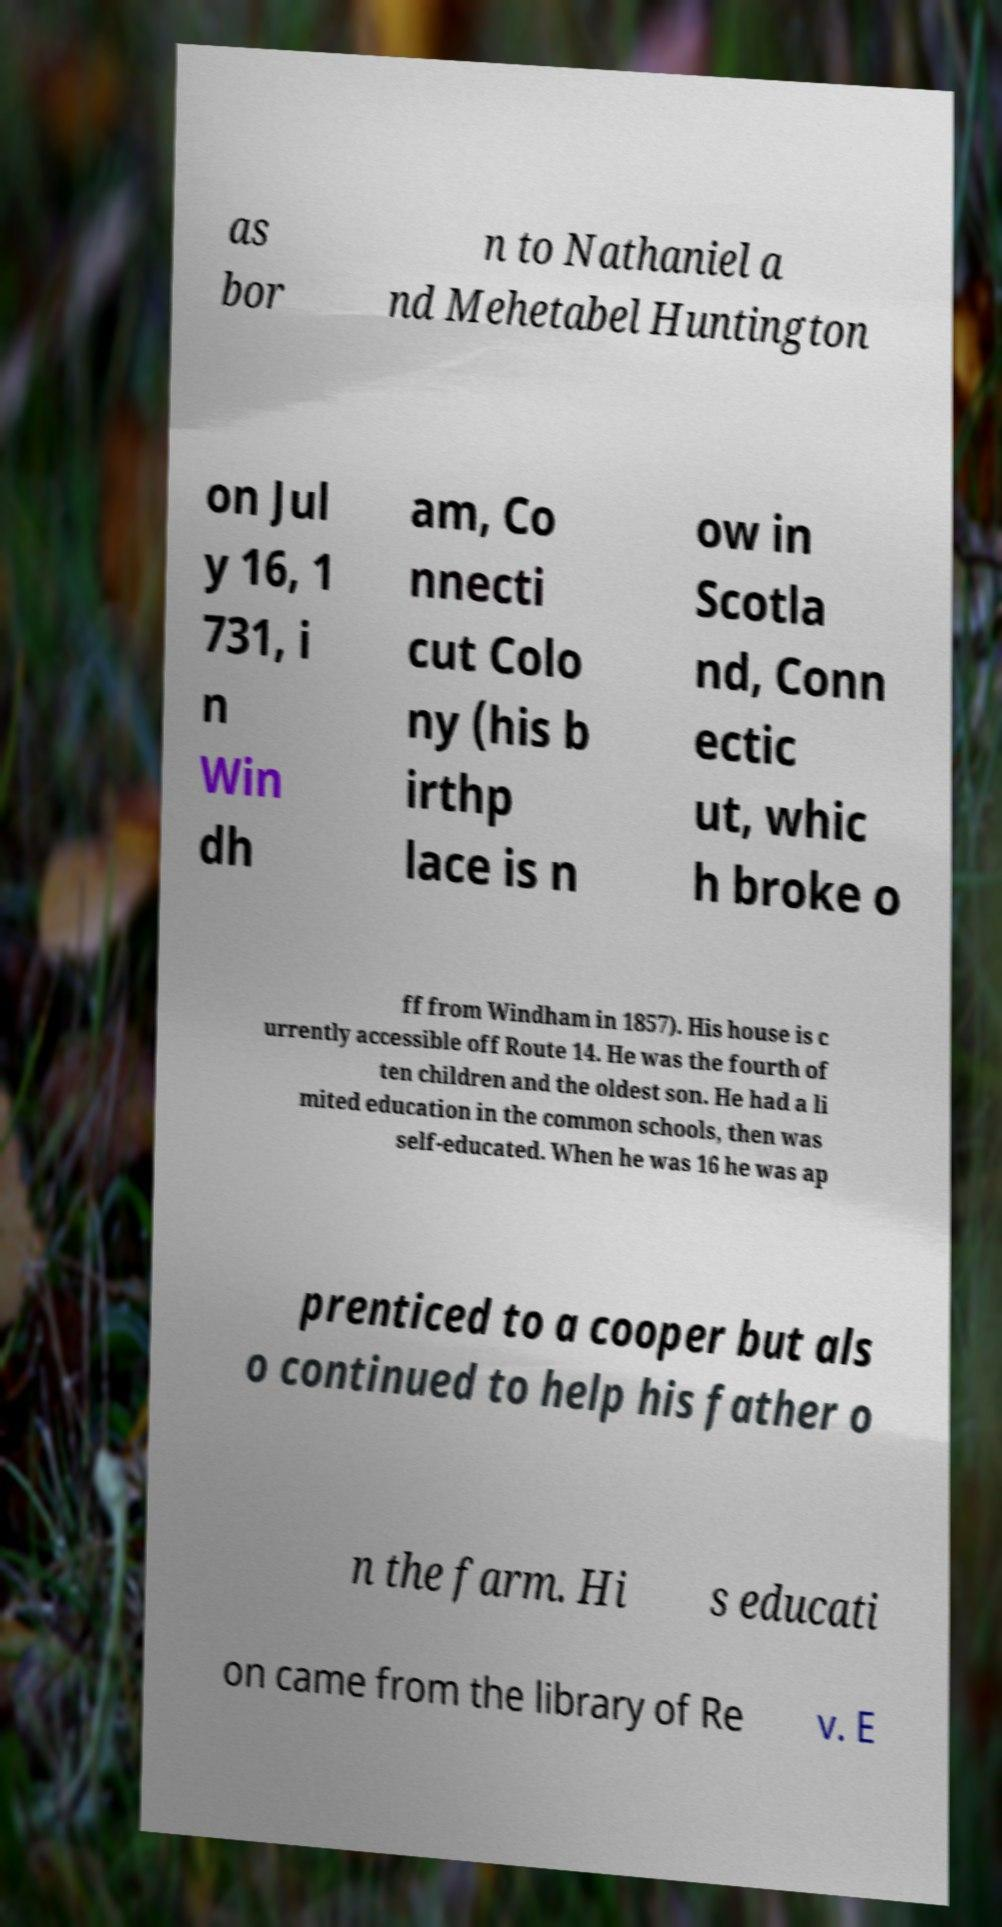Please read and relay the text visible in this image. What does it say? as bor n to Nathaniel a nd Mehetabel Huntington on Jul y 16, 1 731, i n Win dh am, Co nnecti cut Colo ny (his b irthp lace is n ow in Scotla nd, Conn ectic ut, whic h broke o ff from Windham in 1857). His house is c urrently accessible off Route 14. He was the fourth of ten children and the oldest son. He had a li mited education in the common schools, then was self-educated. When he was 16 he was ap prenticed to a cooper but als o continued to help his father o n the farm. Hi s educati on came from the library of Re v. E 